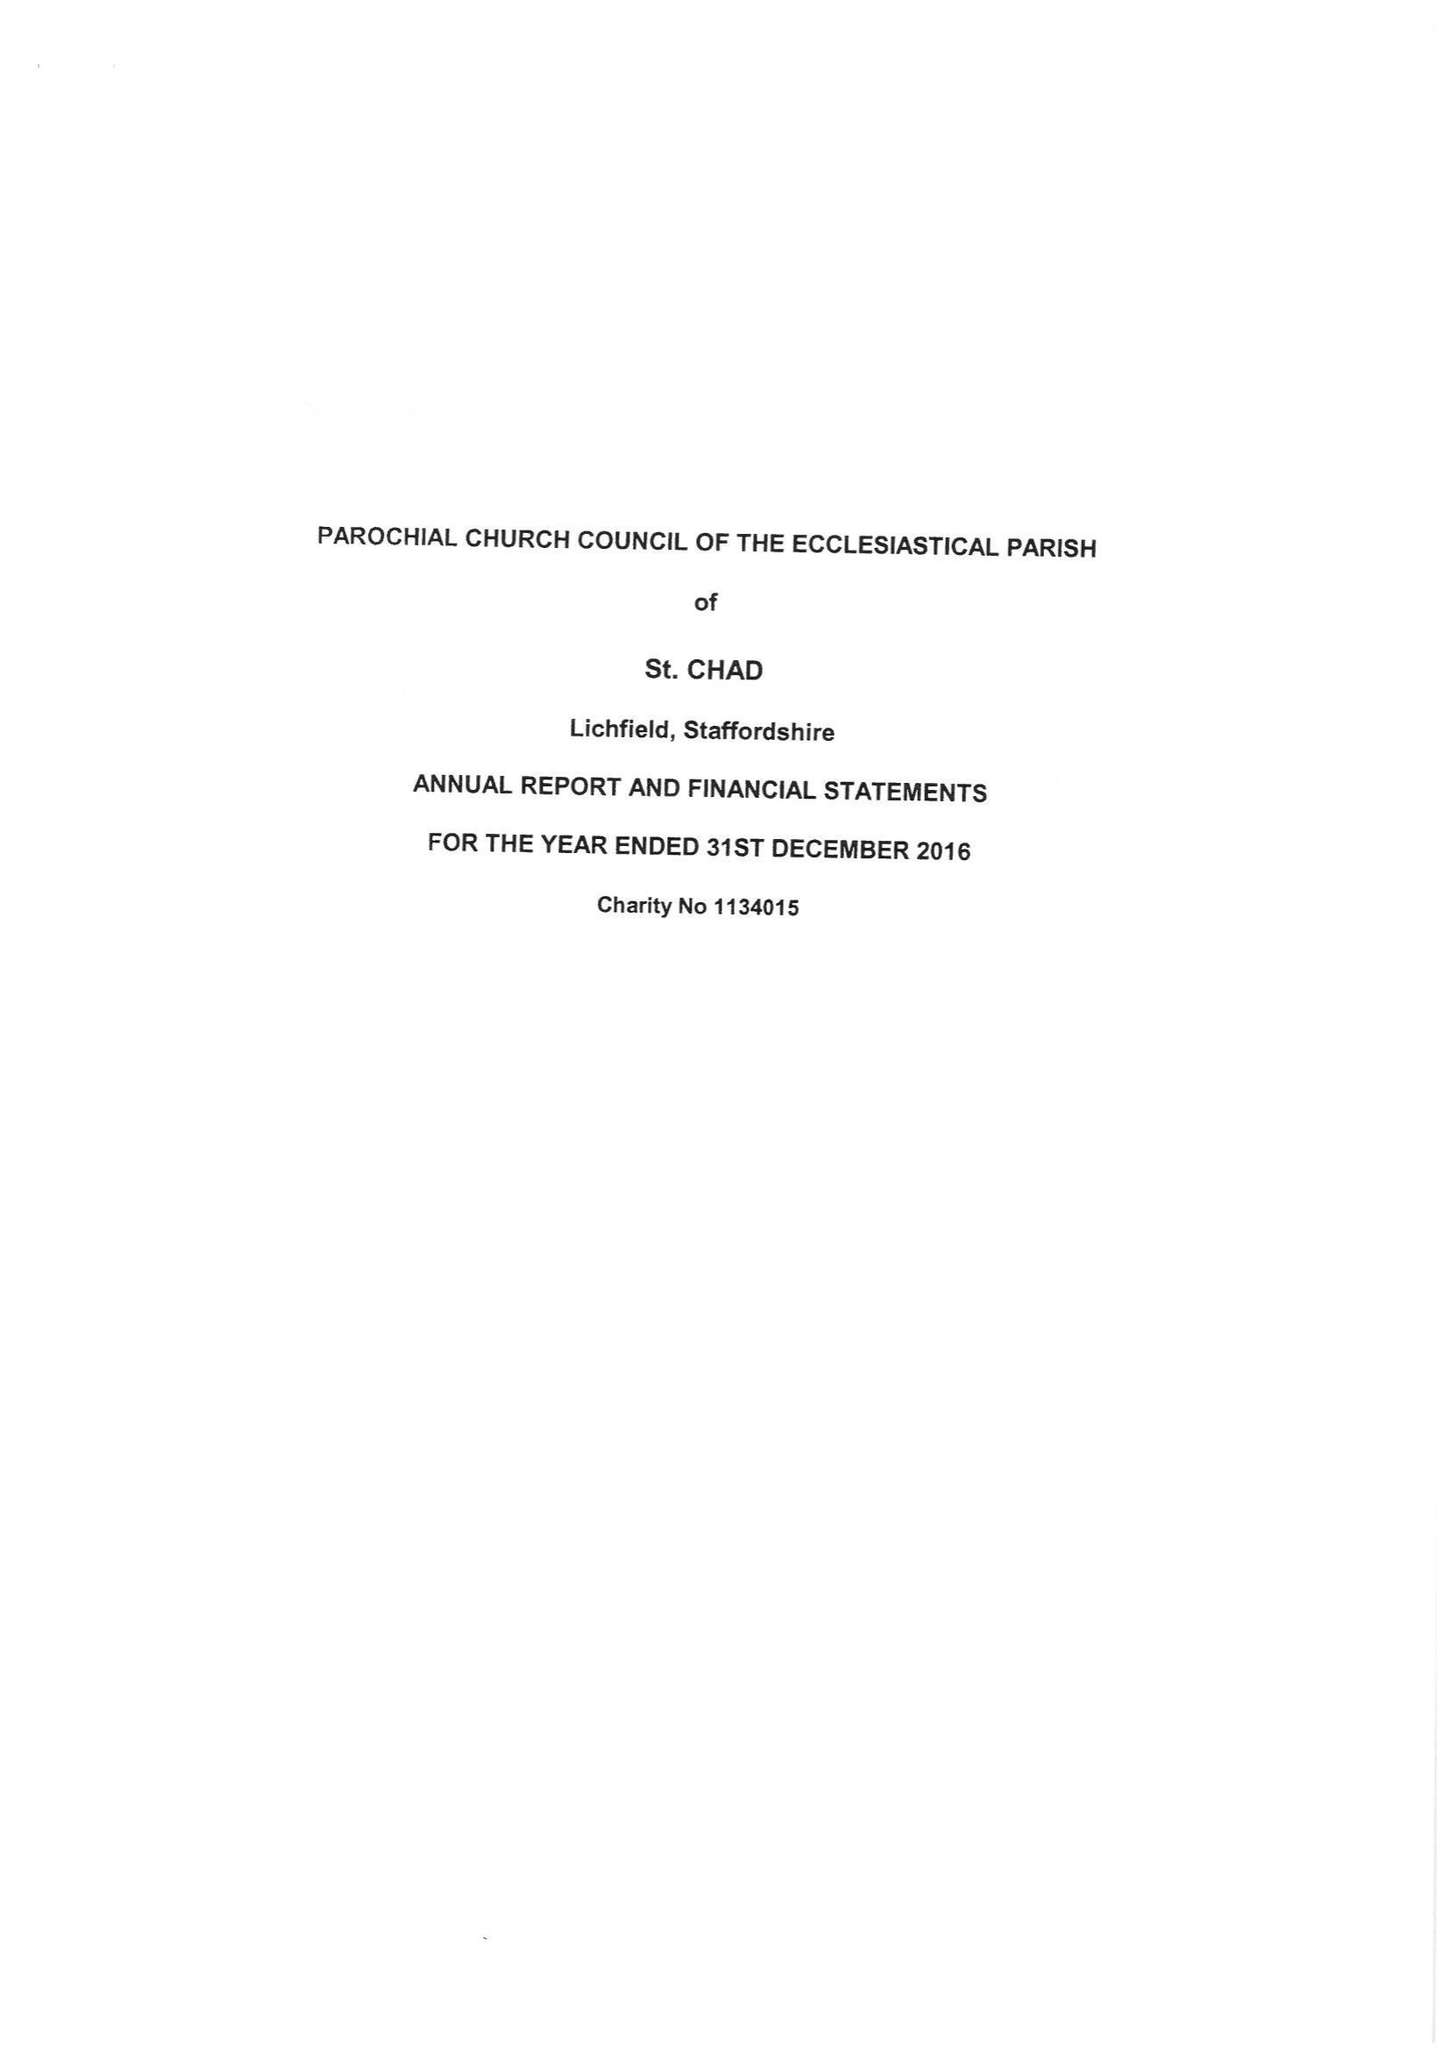What is the value for the report_date?
Answer the question using a single word or phrase. 2016-12-31 